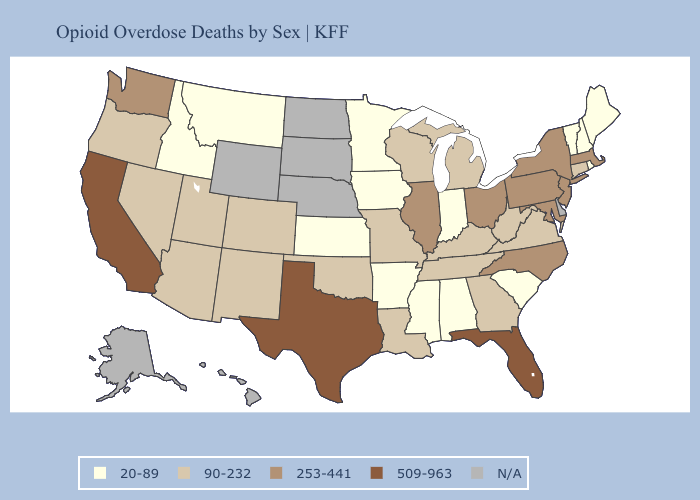Which states have the lowest value in the South?
Quick response, please. Alabama, Arkansas, Mississippi, South Carolina. Among the states that border Nevada , which have the highest value?
Short answer required. California. What is the highest value in the USA?
Quick response, please. 509-963. Name the states that have a value in the range 20-89?
Write a very short answer. Alabama, Arkansas, Idaho, Indiana, Iowa, Kansas, Maine, Minnesota, Mississippi, Montana, New Hampshire, Rhode Island, South Carolina, Vermont. Does Missouri have the lowest value in the USA?
Answer briefly. No. What is the highest value in states that border Virginia?
Give a very brief answer. 253-441. What is the highest value in the USA?
Give a very brief answer. 509-963. Does Ohio have the lowest value in the USA?
Answer briefly. No. Among the states that border Texas , does Arkansas have the lowest value?
Quick response, please. Yes. What is the highest value in the MidWest ?
Write a very short answer. 253-441. What is the highest value in the South ?
Give a very brief answer. 509-963. How many symbols are there in the legend?
Keep it brief. 5. 